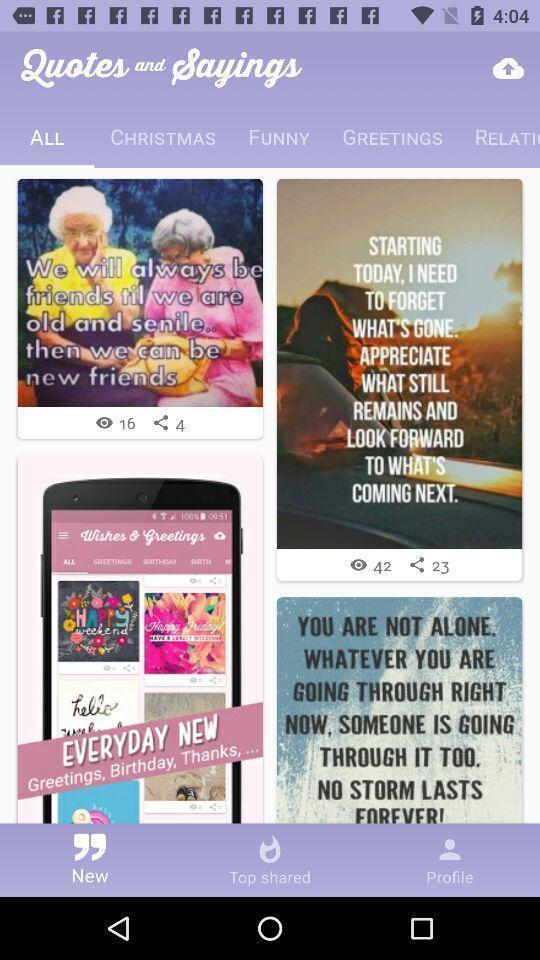Describe the visual elements of this screenshot. Page showing the list of images with quotes. 